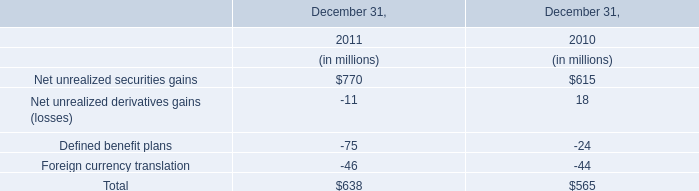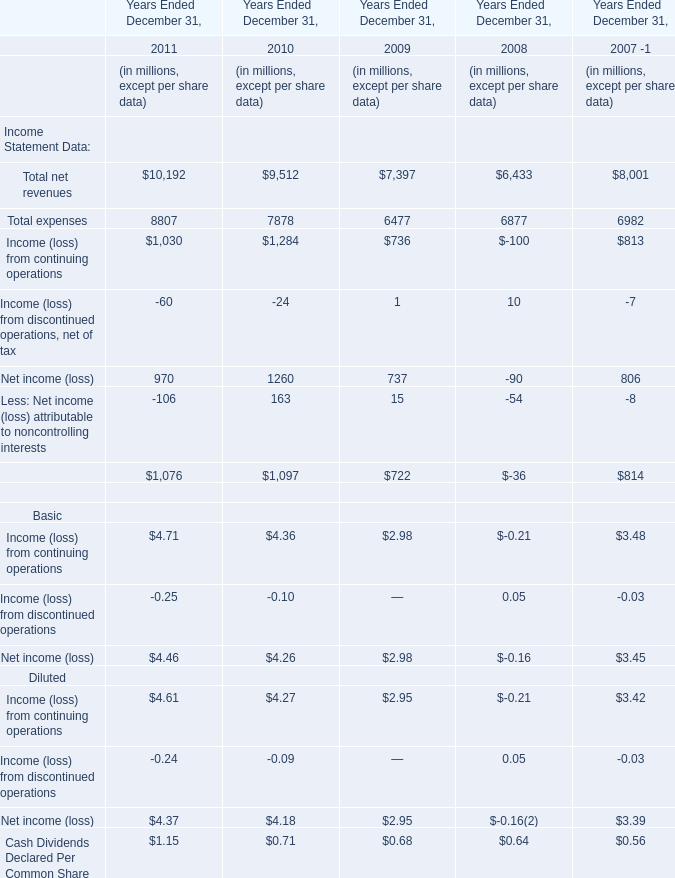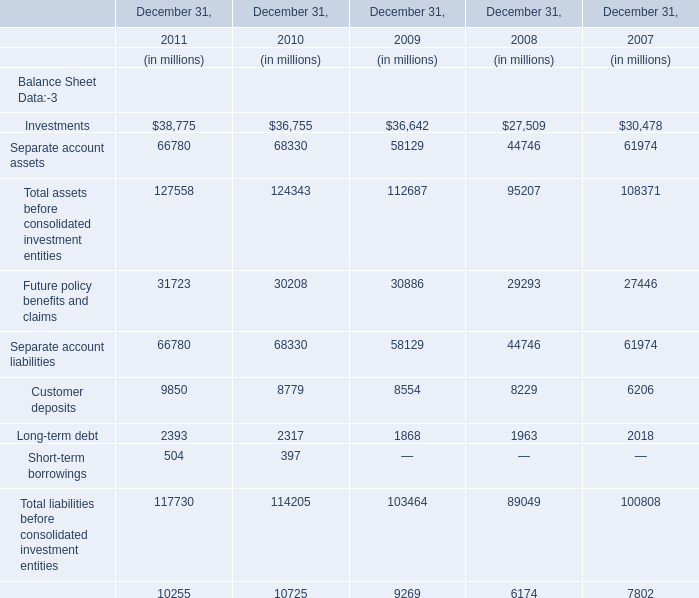What's the sum of Long-term debt and Short-term borrowings in 2011? (in million) 
Computations: (2393 + 504)
Answer: 2897.0. 